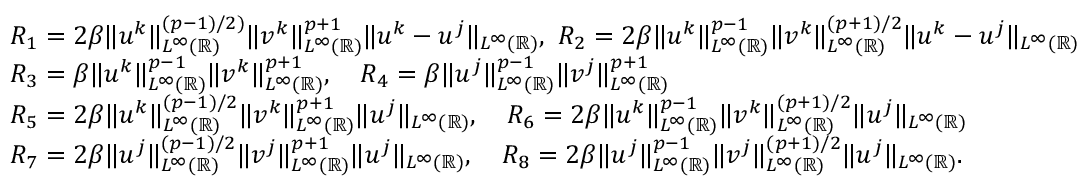Convert formula to latex. <formula><loc_0><loc_0><loc_500><loc_500>\begin{array} { r l } & { R _ { 1 } = 2 \beta \| u ^ { k } \| _ { L ^ { \infty } ( \mathbb { R } ) } ^ { ( p - 1 ) / 2 ) } \| v ^ { k } \| _ { L ^ { \infty } ( \mathbb { R } ) } ^ { p + 1 } \| u ^ { k } - u ^ { j } \| _ { L ^ { \infty } ( \mathbb { R } ) } , \ R _ { 2 } = 2 \beta \| u ^ { k } \| _ { L ^ { \infty } ( \mathbb { R } ) } ^ { p - 1 } \| v ^ { k } \| _ { L ^ { \infty } ( \mathbb { R } ) } ^ { ( p + 1 ) / 2 } \| u ^ { k } - u ^ { j } \| _ { L ^ { \infty } ( \mathbb { R } ) } } \\ & { R _ { 3 } = \beta \| u ^ { k } \| _ { L ^ { \infty } ( \mathbb { R } ) } ^ { p - 1 } \| v ^ { k } \| _ { L ^ { \infty } ( \mathbb { R } ) } ^ { p + 1 } , \quad R _ { 4 } = \beta \| u ^ { j } \| _ { L ^ { \infty } ( \mathbb { R } ) } ^ { p - 1 } \| v ^ { j } \| _ { L ^ { \infty } ( \mathbb { R } ) } ^ { p + 1 } } \\ & { R _ { 5 } = 2 \beta \| u ^ { k } \| _ { L ^ { \infty } ( \mathbb { R } ) } ^ { ( p - 1 ) / 2 } \| v ^ { k } \| _ { L ^ { \infty } ( \mathbb { R } ) } ^ { p + 1 } \| u ^ { j } \| _ { L ^ { \infty } ( \mathbb { R } ) } , \quad R _ { 6 } = 2 \beta \| u ^ { k } \| _ { L ^ { \infty } ( \mathbb { R } ) } ^ { p - 1 } \| v ^ { k } \| _ { L ^ { \infty } ( \mathbb { R } ) } ^ { ( p + 1 ) / 2 } \| u ^ { j } \| _ { L ^ { \infty } ( \mathbb { R } ) } } \\ & { R _ { 7 } = 2 \beta \| u ^ { j } \| _ { L ^ { \infty } ( \mathbb { R } ) } ^ { ( p - 1 ) / 2 } \| v ^ { j } \| _ { L ^ { \infty } ( \mathbb { R } ) } ^ { p + 1 } \| u ^ { j } \| _ { L ^ { \infty } ( \mathbb { R } ) } , \quad R _ { 8 } = 2 \beta \| u ^ { j } \| _ { L ^ { \infty } ( \mathbb { R } ) } ^ { p - 1 } \| v ^ { j } \| _ { L ^ { \infty } ( \mathbb { R } ) } ^ { ( p + 1 ) / 2 } \| u ^ { j } \| _ { L ^ { \infty } ( \mathbb { R } ) } . } \end{array}</formula> 